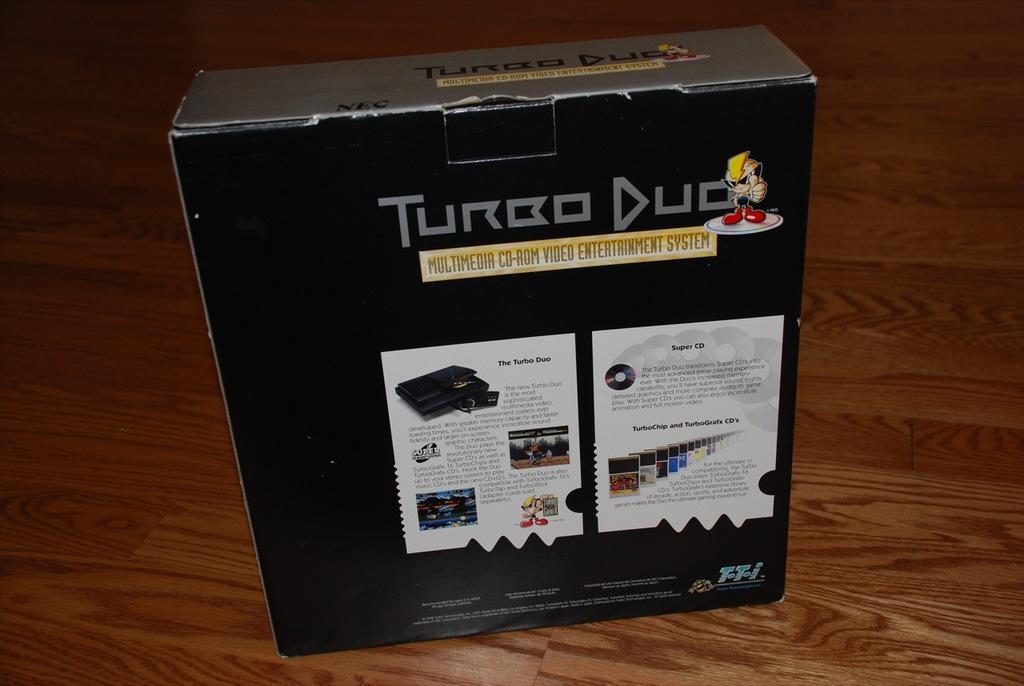How would you summarize this image in a sentence or two? This image consists of a box in black color. It looks like a video game box. At the bottom, there is a floor. 